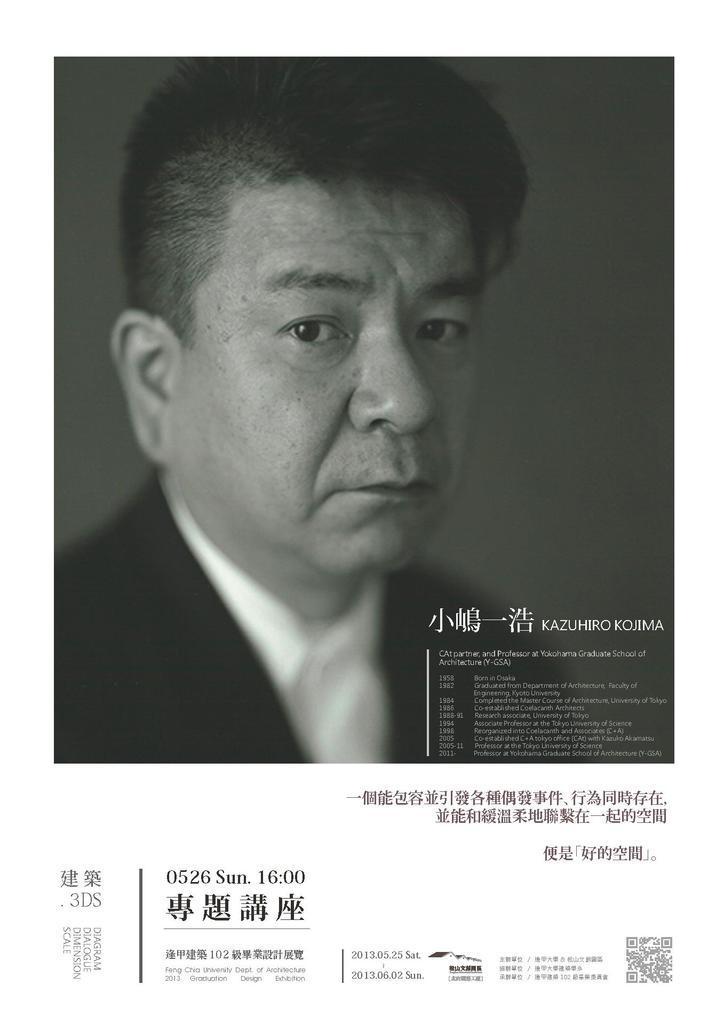How would you summarize this image in a sentence or two? In this picture I can see there is a man standing and he is wearing a black blazer, white shirt and there is something written here on the picture. 